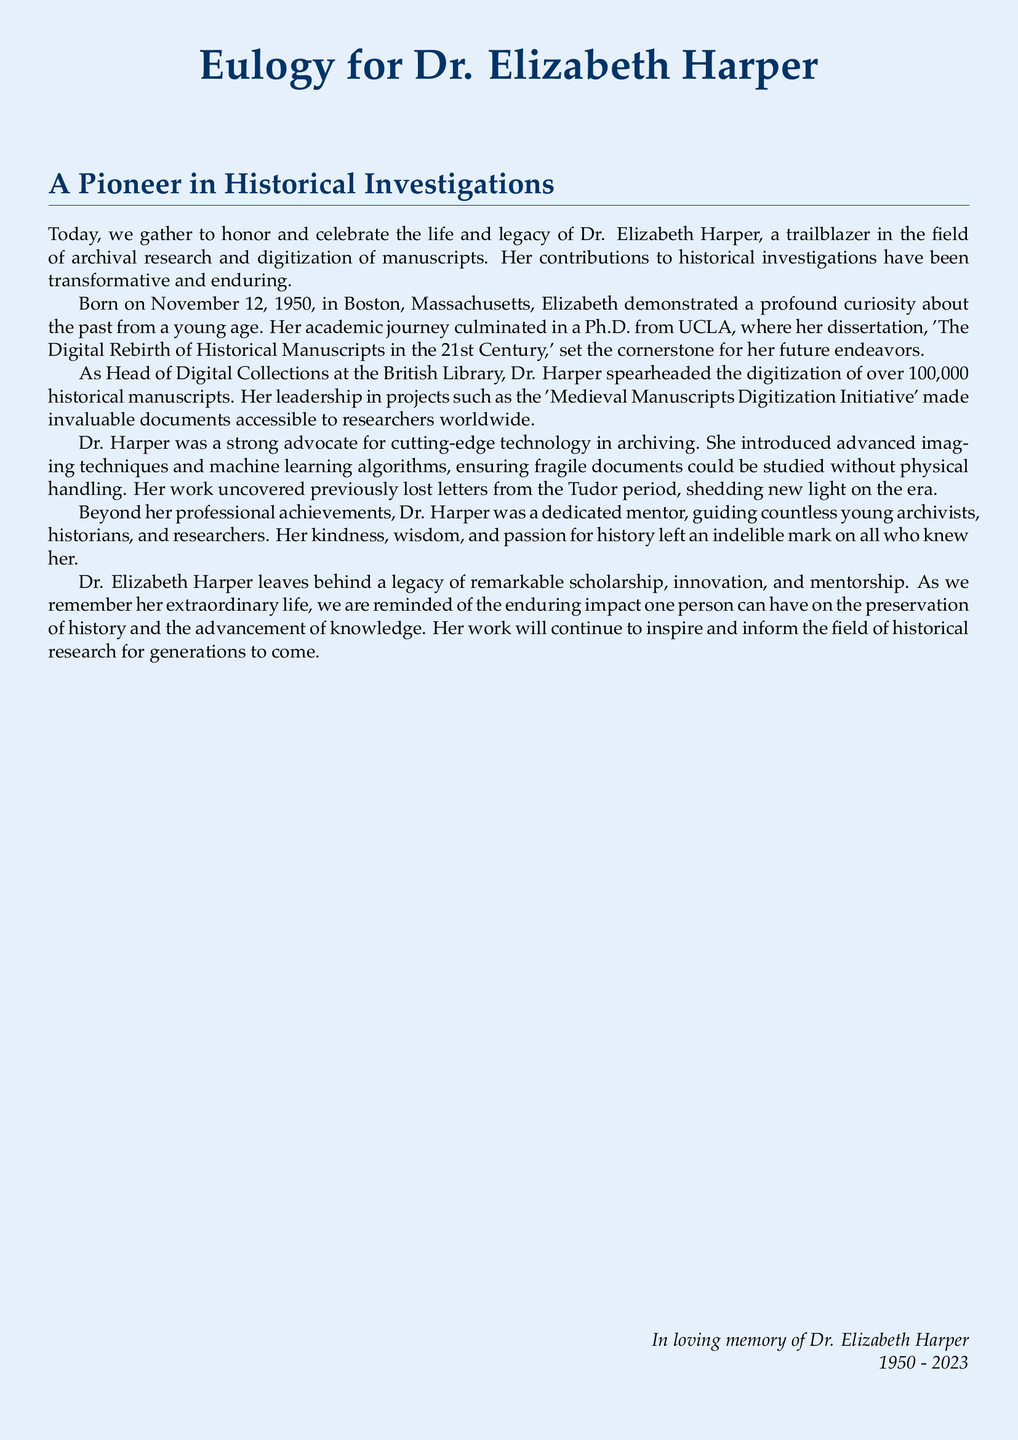What is the full name of the person being honored? The document provides the full name of the individual being honored, which is Dr. Elizabeth Harper.
Answer: Dr. Elizabeth Harper When was Dr. Elizabeth Harper born? The document specifies the birth date of Dr. Elizabeth Harper as November 12, 1950.
Answer: November 12, 1950 What role did Dr. Harper hold at the British Library? The document states that Dr. Harper was the Head of Digital Collections at the British Library.
Answer: Head of Digital Collections How many historical manuscripts did Dr. Harper help digitize? The document mentions that Dr. Harper spearheaded the digitization of over 100,000 historical manuscripts.
Answer: over 100,000 What is the title of Dr. Harper's dissertation? The document reflects on her academic work, specifically noting her dissertation's title as 'The Digital Rebirth of Historical Manuscripts in the 21st Century.'
Answer: The Digital Rebirth of Historical Manuscripts in the 21st Century What innovative techniques did Dr. Harper introduce? The document highlights Dr. Harper's introduction of advanced imaging techniques and machine learning algorithms.
Answer: advanced imaging techniques and machine learning algorithms What prestigious initiative did Dr. Harper lead? The document references the 'Medieval Manuscripts Digitization Initiative' as one of her key projects.
Answer: Medieval Manuscripts Digitization Initiative What qualities did Dr. Harper embody as a mentor? The document emphasizes her kindness, wisdom, and passion for history as key qualities.
Answer: kindness, wisdom, and passion for history What was Dr. Harper's legacy focused on? The document expresses that Dr. Harper's legacy consisted of remarkable scholarship, innovation, and mentorship.
Answer: remarkable scholarship, innovation, and mentorship 